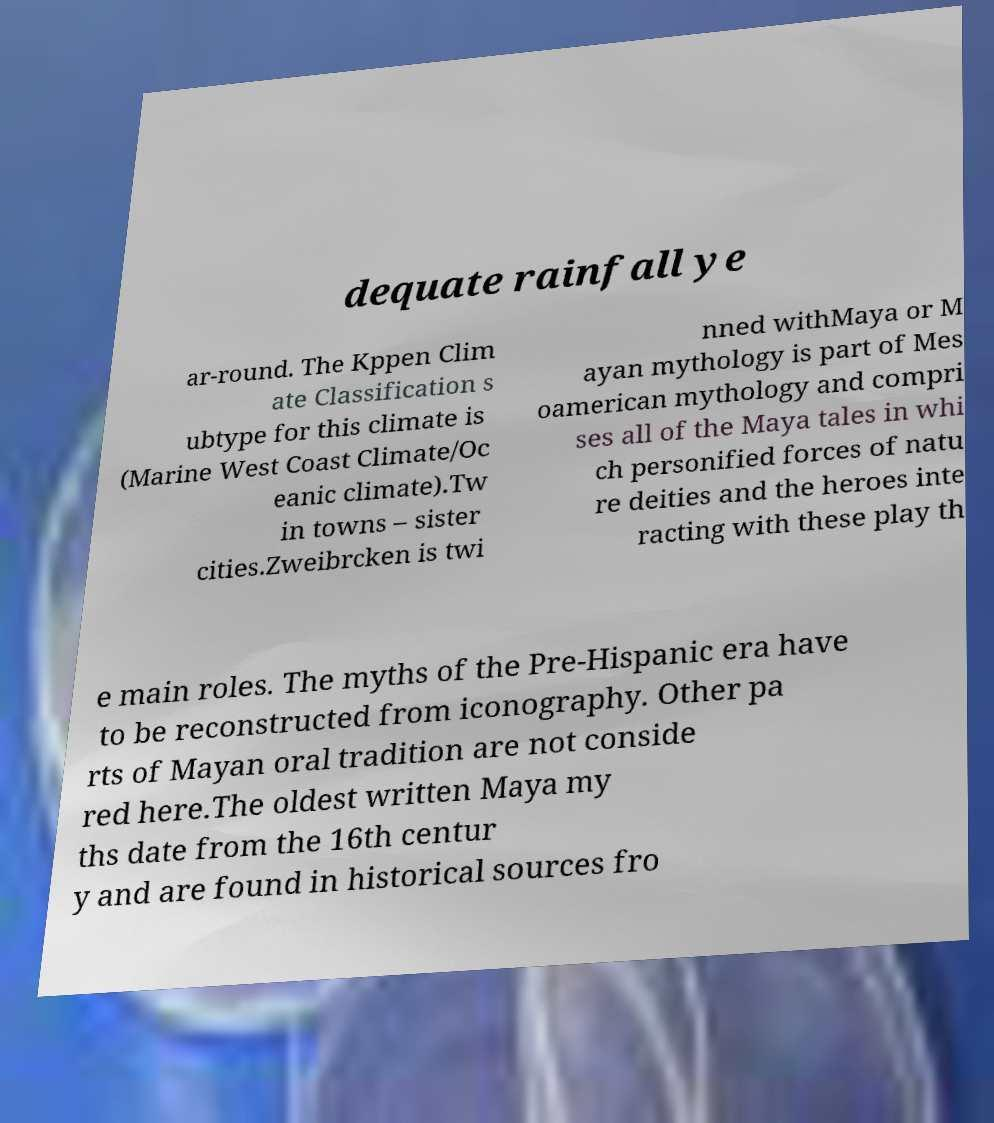Could you extract and type out the text from this image? dequate rainfall ye ar-round. The Kppen Clim ate Classification s ubtype for this climate is (Marine West Coast Climate/Oc eanic climate).Tw in towns – sister cities.Zweibrcken is twi nned withMaya or M ayan mythology is part of Mes oamerican mythology and compri ses all of the Maya tales in whi ch personified forces of natu re deities and the heroes inte racting with these play th e main roles. The myths of the Pre-Hispanic era have to be reconstructed from iconography. Other pa rts of Mayan oral tradition are not conside red here.The oldest written Maya my ths date from the 16th centur y and are found in historical sources fro 